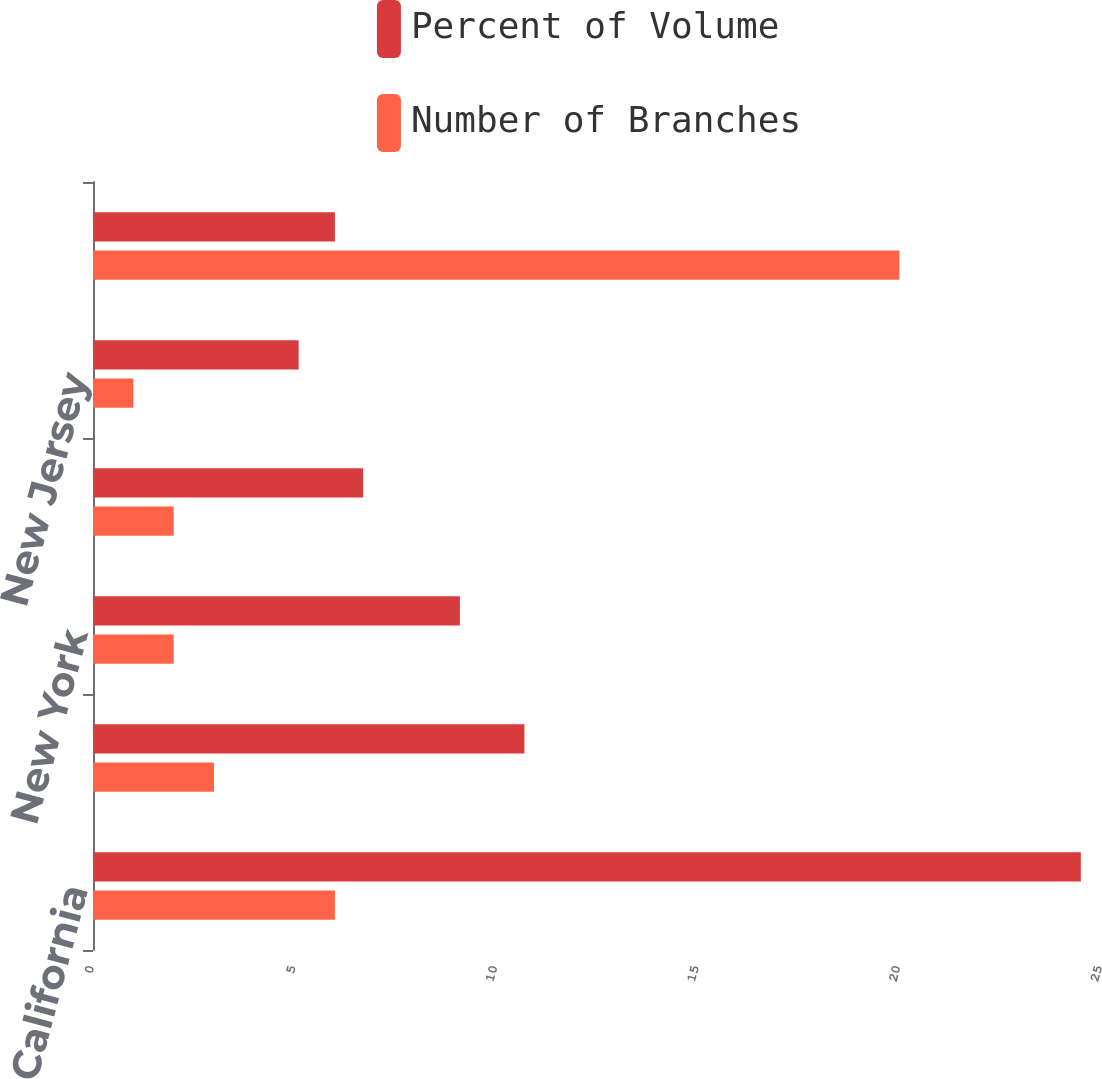Convert chart. <chart><loc_0><loc_0><loc_500><loc_500><stacked_bar_chart><ecel><fcel>California<fcel>Florida<fcel>New York<fcel>Massachusetts<fcel>New Jersey<fcel>Other<nl><fcel>Percent of Volume<fcel>24.5<fcel>10.7<fcel>9.1<fcel>6.7<fcel>5.1<fcel>6<nl><fcel>Number of Branches<fcel>6<fcel>3<fcel>2<fcel>2<fcel>1<fcel>20<nl></chart> 